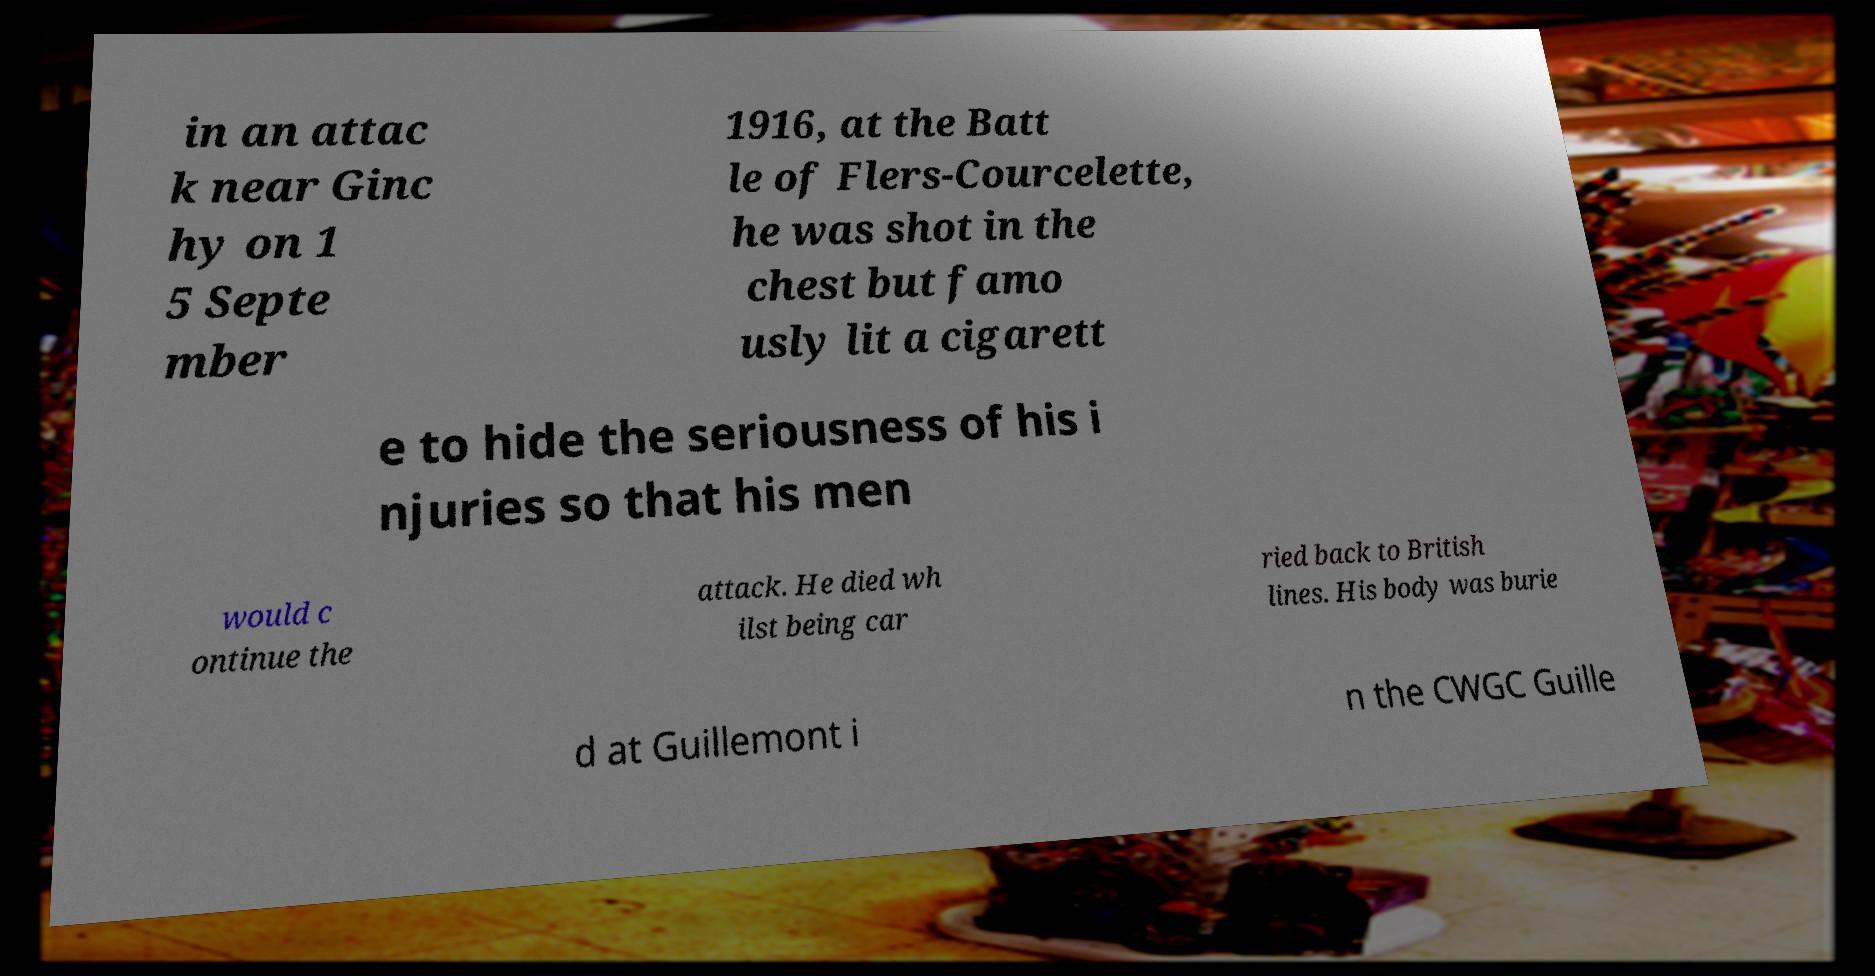There's text embedded in this image that I need extracted. Can you transcribe it verbatim? in an attac k near Ginc hy on 1 5 Septe mber 1916, at the Batt le of Flers-Courcelette, he was shot in the chest but famo usly lit a cigarett e to hide the seriousness of his i njuries so that his men would c ontinue the attack. He died wh ilst being car ried back to British lines. His body was burie d at Guillemont i n the CWGC Guille 